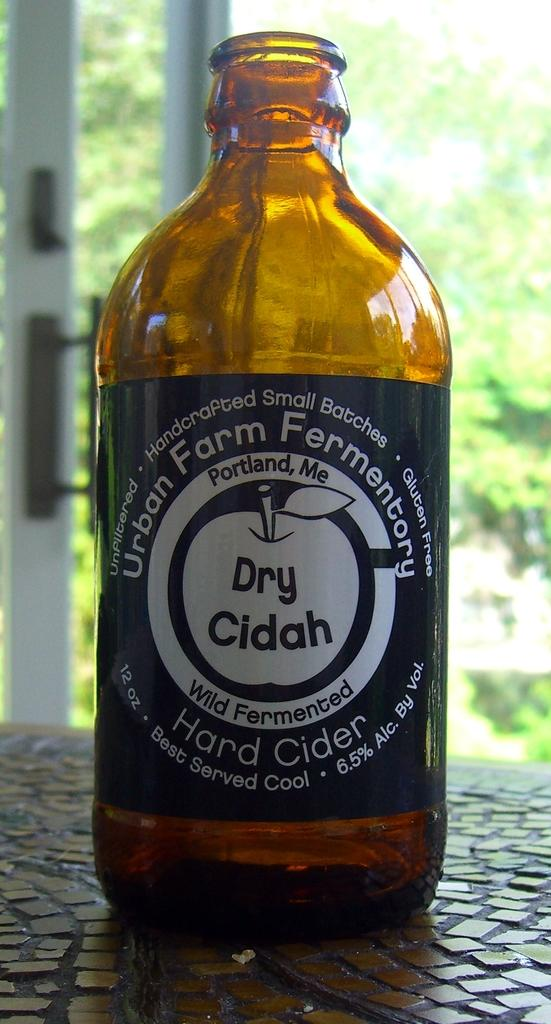<image>
Offer a succinct explanation of the picture presented. A bottle of Dry Cidah sits opened on a mosaic table. 